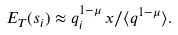Convert formula to latex. <formula><loc_0><loc_0><loc_500><loc_500>E _ { T } ( s _ { i } ) \approx q _ { i } ^ { 1 - \mu } \, x / \langle q ^ { 1 - \mu } \rangle .</formula> 